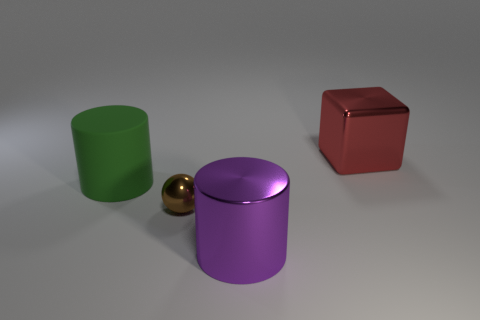Add 3 large yellow metal objects. How many objects exist? 7 Subtract all cubes. How many objects are left? 3 Add 3 big green objects. How many big green objects exist? 4 Subtract 0 brown cubes. How many objects are left? 4 Subtract all metallic objects. Subtract all tiny brown objects. How many objects are left? 0 Add 4 large metal cylinders. How many large metal cylinders are left? 5 